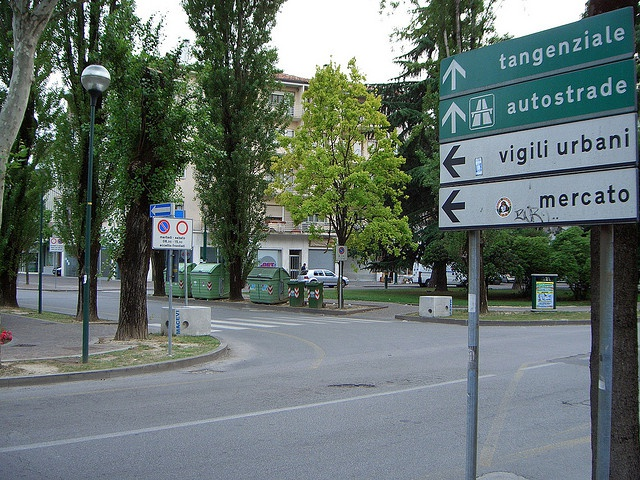Describe the objects in this image and their specific colors. I can see car in black, white, gray, and darkgray tones, car in black, darkgray, and gray tones, car in black, gray, navy, and white tones, and people in black, navy, darkgray, and gray tones in this image. 